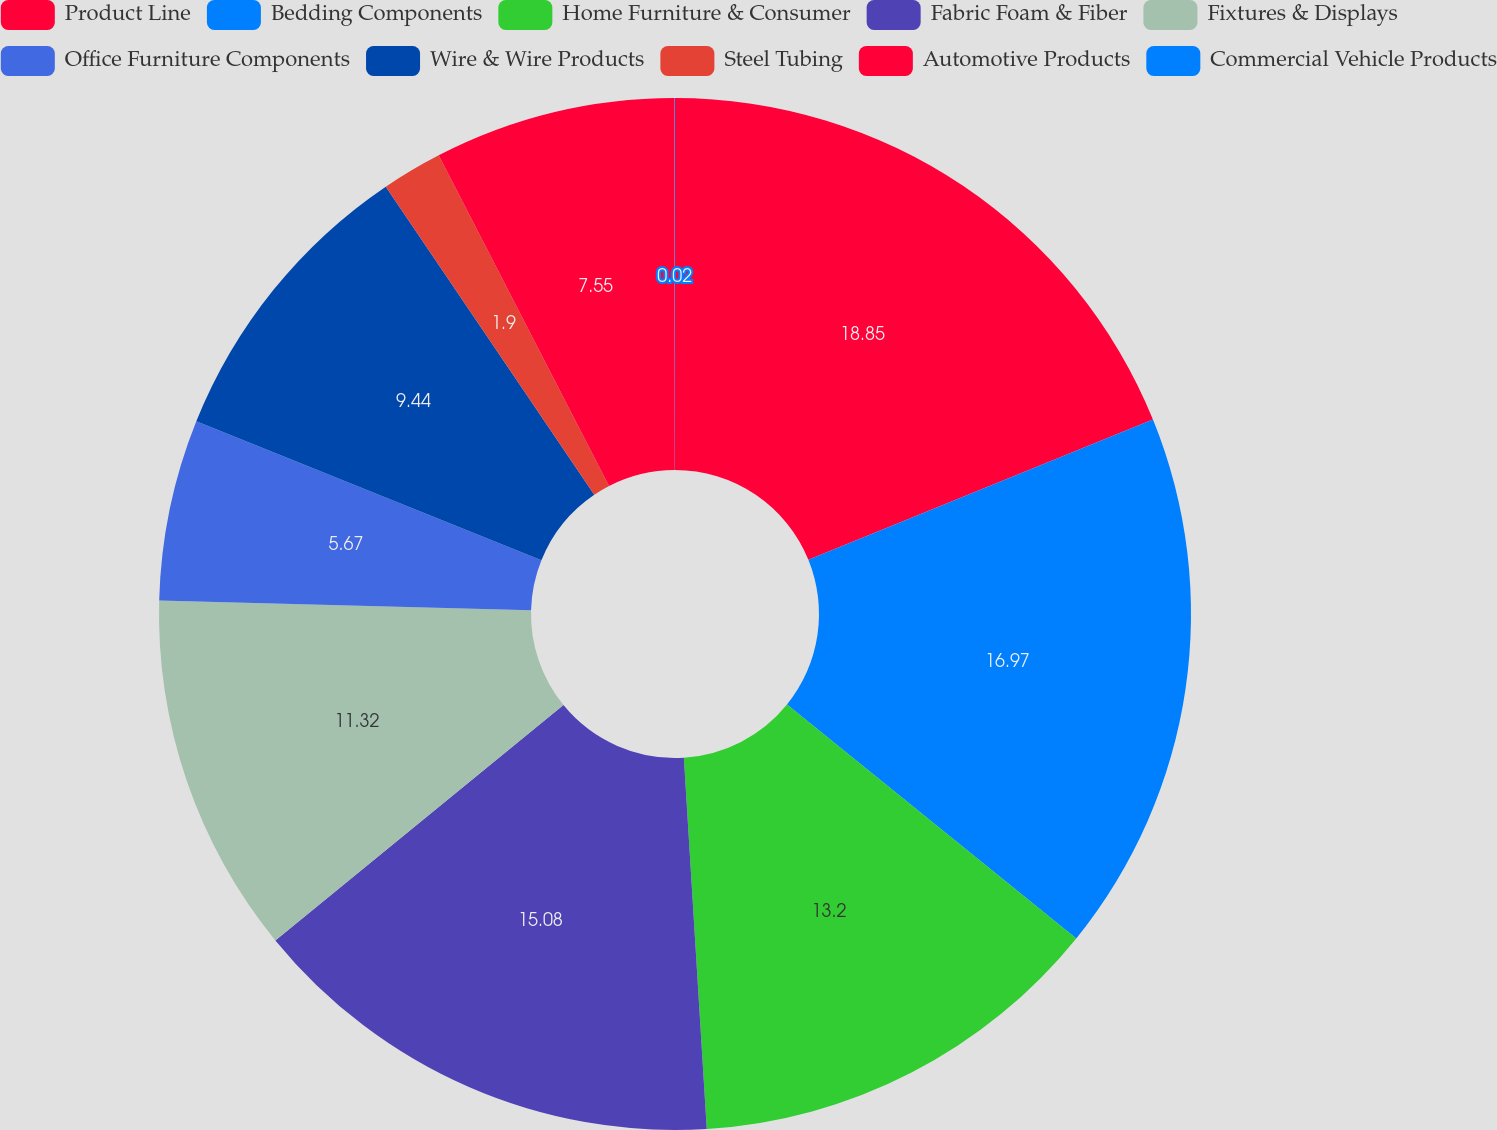<chart> <loc_0><loc_0><loc_500><loc_500><pie_chart><fcel>Product Line<fcel>Bedding Components<fcel>Home Furniture & Consumer<fcel>Fabric Foam & Fiber<fcel>Fixtures & Displays<fcel>Office Furniture Components<fcel>Wire & Wire Products<fcel>Steel Tubing<fcel>Automotive Products<fcel>Commercial Vehicle Products<nl><fcel>18.85%<fcel>16.97%<fcel>13.2%<fcel>15.08%<fcel>11.32%<fcel>5.67%<fcel>9.44%<fcel>1.9%<fcel>7.55%<fcel>0.02%<nl></chart> 